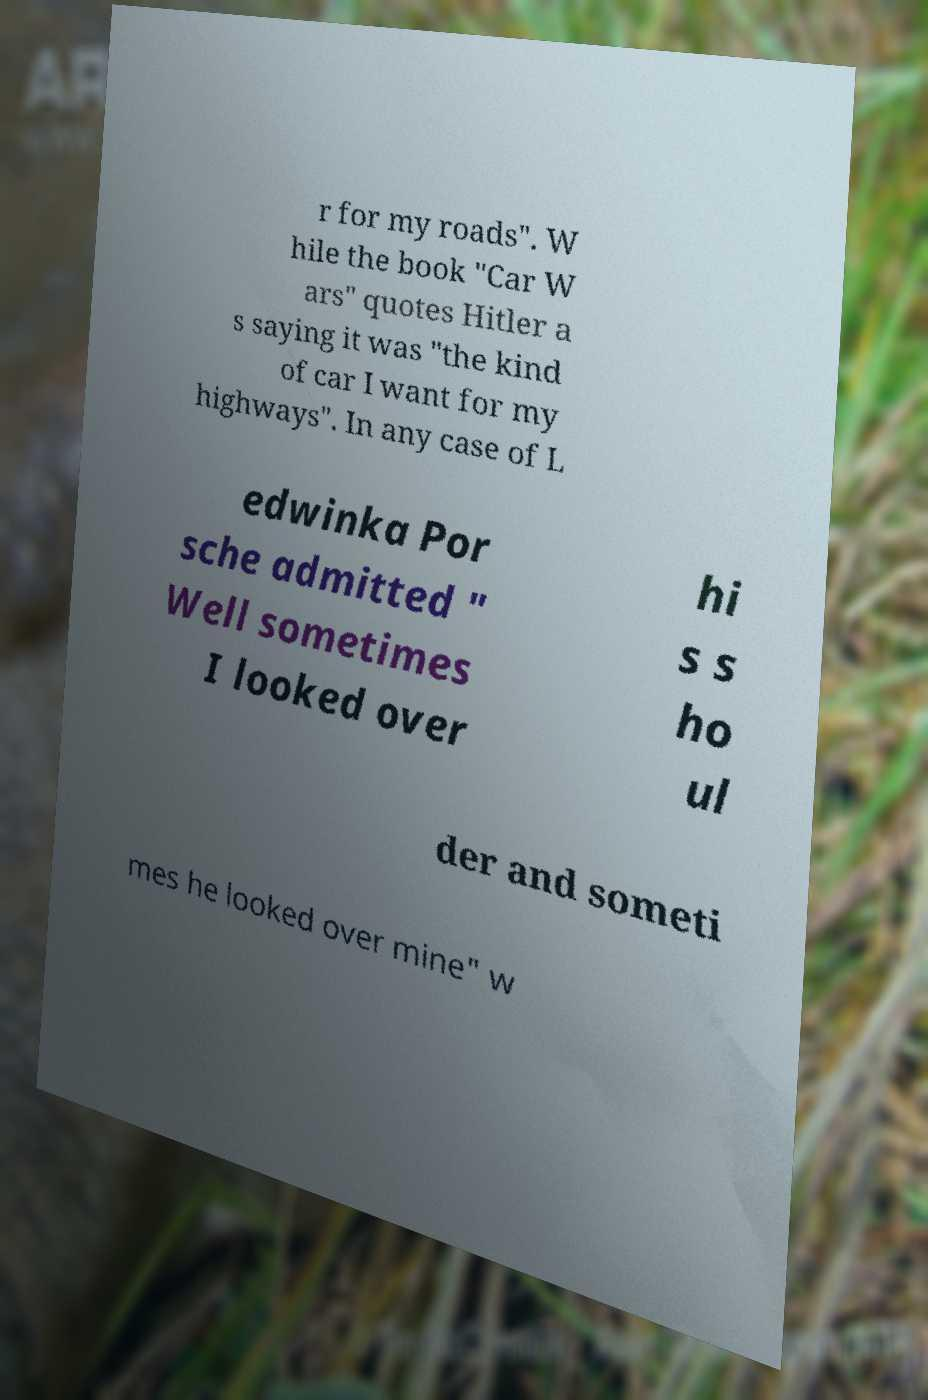There's text embedded in this image that I need extracted. Can you transcribe it verbatim? r for my roads". W hile the book "Car W ars" quotes Hitler a s saying it was "the kind of car I want for my highways". In any case of L edwinka Por sche admitted " Well sometimes I looked over hi s s ho ul der and someti mes he looked over mine" w 